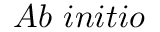Convert formula to latex. <formula><loc_0><loc_0><loc_500><loc_500>A b \ i n i t i o</formula> 